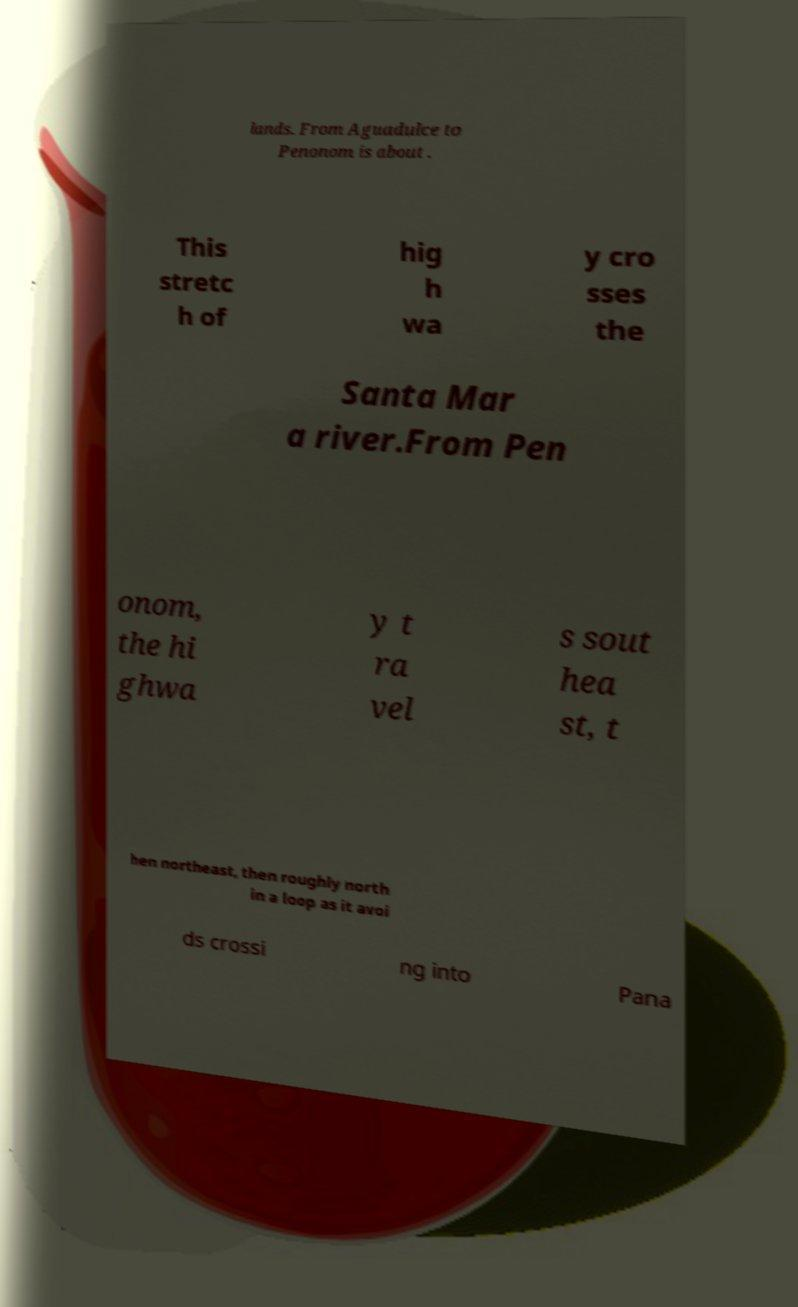Could you extract and type out the text from this image? lands. From Aguadulce to Penonom is about . This stretc h of hig h wa y cro sses the Santa Mar a river.From Pen onom, the hi ghwa y t ra vel s sout hea st, t hen northeast, then roughly north in a loop as it avoi ds crossi ng into Pana 